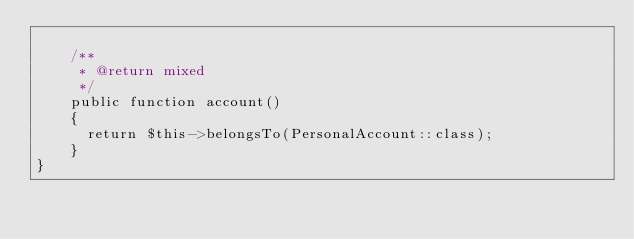<code> <loc_0><loc_0><loc_500><loc_500><_PHP_>
    /**
     * @return mixed
     */
    public function account()
    {
      return $this->belongsTo(PersonalAccount::class);
    }
}
</code> 